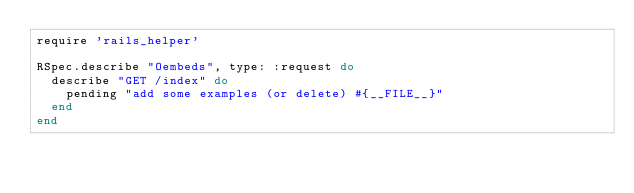Convert code to text. <code><loc_0><loc_0><loc_500><loc_500><_Ruby_>require 'rails_helper'

RSpec.describe "Oembeds", type: :request do
  describe "GET /index" do
    pending "add some examples (or delete) #{__FILE__}"
  end
end
</code> 